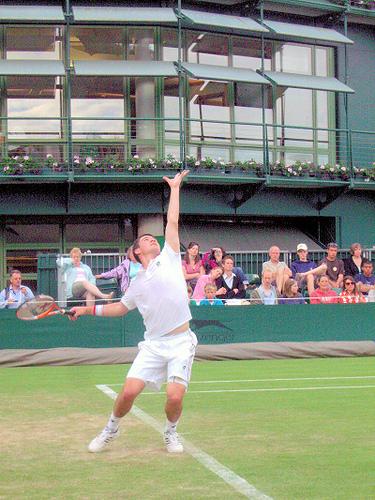Is the entire audience watching the tennis player?
Short answer required. Yes. Do you see steps in the photo?
Keep it brief. No. What is the player doing?
Short answer required. Serving. What sport is being played?
Short answer required. Tennis. What sport is this?
Quick response, please. Tennis. What sport are they playing?
Quick response, please. Tennis. Is the ground grassy?
Be succinct. Yes. Where is the ball?
Be succinct. In air. 